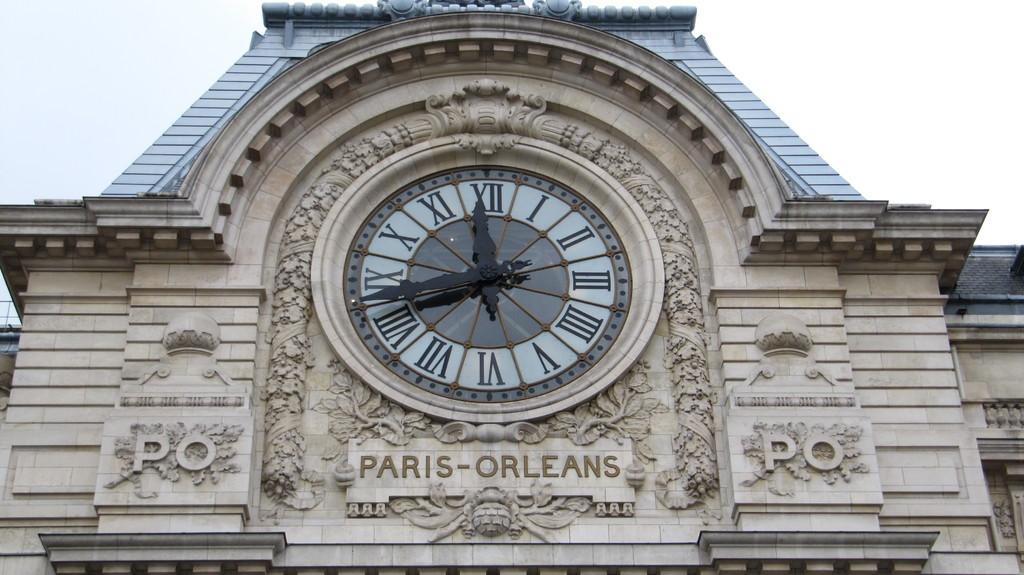<image>
Offer a succinct explanation of the picture presented. Clock on a building with the words "Paris-Orleans" below it. 